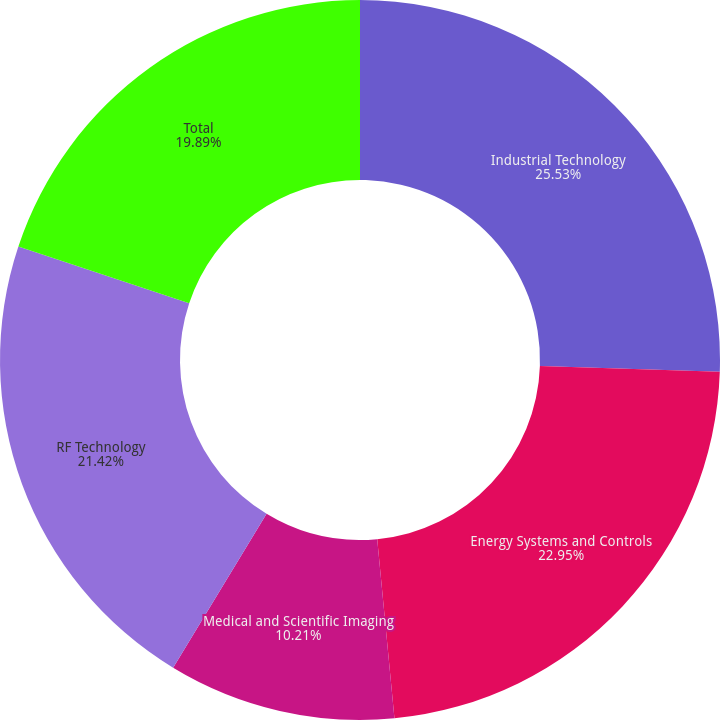Convert chart to OTSL. <chart><loc_0><loc_0><loc_500><loc_500><pie_chart><fcel>Industrial Technology<fcel>Energy Systems and Controls<fcel>Medical and Scientific Imaging<fcel>RF Technology<fcel>Total<nl><fcel>25.52%<fcel>22.95%<fcel>10.21%<fcel>21.42%<fcel>19.89%<nl></chart> 